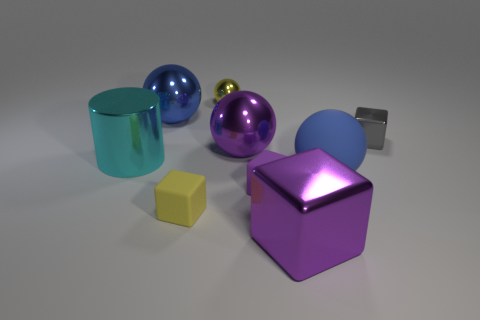Subtract all yellow shiny balls. How many balls are left? 3 Subtract all yellow balls. How many balls are left? 3 Subtract all cylinders. How many objects are left? 8 Subtract 2 blocks. How many blocks are left? 2 Subtract all purple balls. How many gray cubes are left? 1 Subtract 0 blue cubes. How many objects are left? 9 Subtract all blue balls. Subtract all green cylinders. How many balls are left? 2 Subtract all tiny blue metal objects. Subtract all big purple shiny cubes. How many objects are left? 8 Add 7 purple metal cubes. How many purple metal cubes are left? 8 Add 6 yellow matte objects. How many yellow matte objects exist? 7 